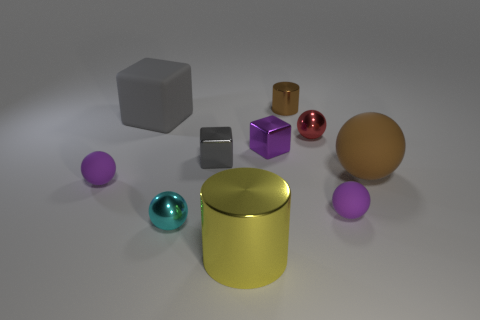What shapes and colors do we see in the collection of objects present? The collection includes objects in various shapes: a sphere, cylinder, cube, and more. The colors range from metallic hues like gold and silver to vibrant tones such as cyan, purple, and red. 